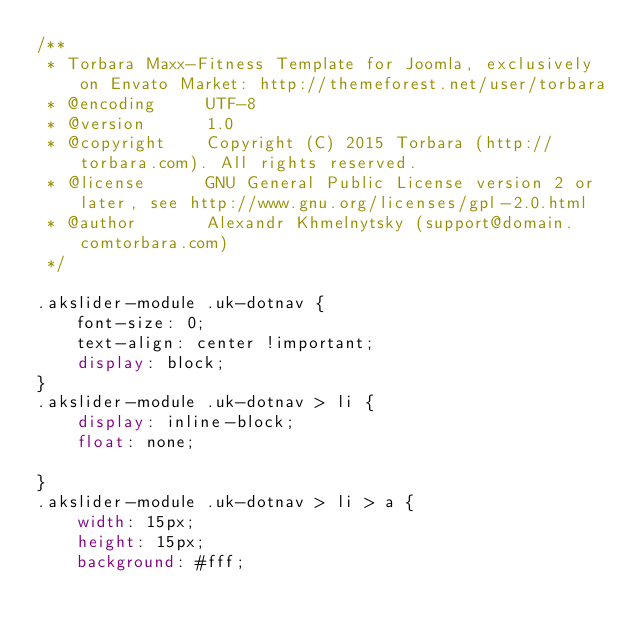<code> <loc_0><loc_0><loc_500><loc_500><_CSS_>/**
 * Torbara Maxx-Fitness Template for Joomla, exclusively on Envato Market: http://themeforest.net/user/torbara
 * @encoding     UTF-8
 * @version      1.0
 * @copyright    Copyright (C) 2015 Torbara (http://torbara.com). All rights reserved.
 * @license      GNU General Public License version 2 or later, see http://www.gnu.org/licenses/gpl-2.0.html
 * @author       Alexandr Khmelnytsky (support@domain.comtorbara.com)
 */

.akslider-module .uk-dotnav {
    font-size: 0;
    text-align: center !important;
    display: block;
}
.akslider-module .uk-dotnav > li {
    display: inline-block;
    float: none;
    
}
.akslider-module .uk-dotnav > li > a {
    width: 15px;
    height: 15px;
    background: #fff;</code> 